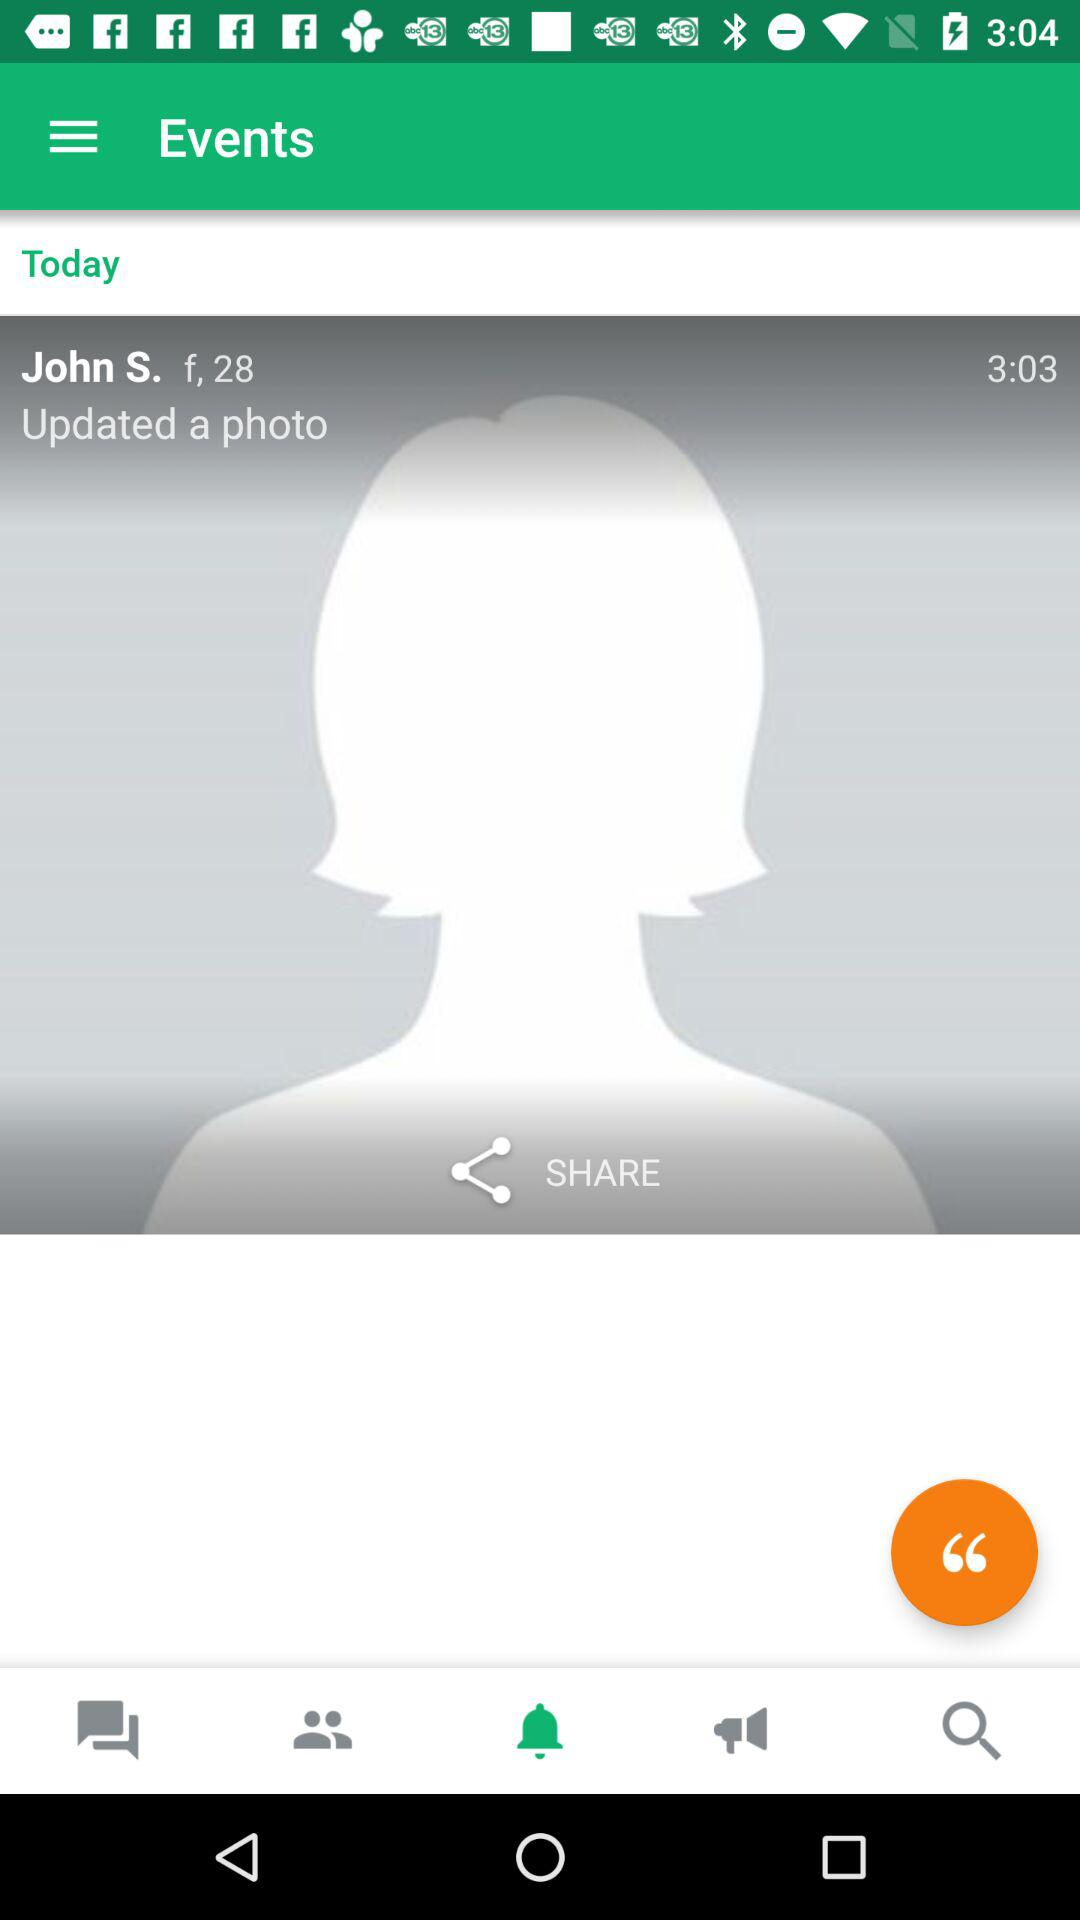What is the user name? The user name is John S. 